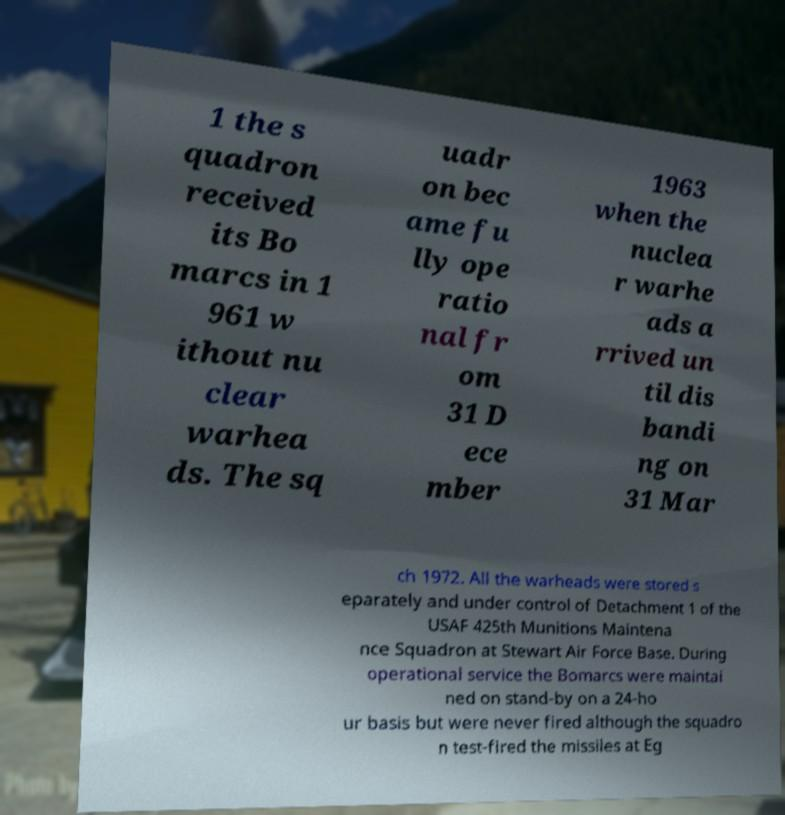Can you read and provide the text displayed in the image?This photo seems to have some interesting text. Can you extract and type it out for me? 1 the s quadron received its Bo marcs in 1 961 w ithout nu clear warhea ds. The sq uadr on bec ame fu lly ope ratio nal fr om 31 D ece mber 1963 when the nuclea r warhe ads a rrived un til dis bandi ng on 31 Mar ch 1972. All the warheads were stored s eparately and under control of Detachment 1 of the USAF 425th Munitions Maintena nce Squadron at Stewart Air Force Base. During operational service the Bomarcs were maintai ned on stand-by on a 24-ho ur basis but were never fired although the squadro n test-fired the missiles at Eg 